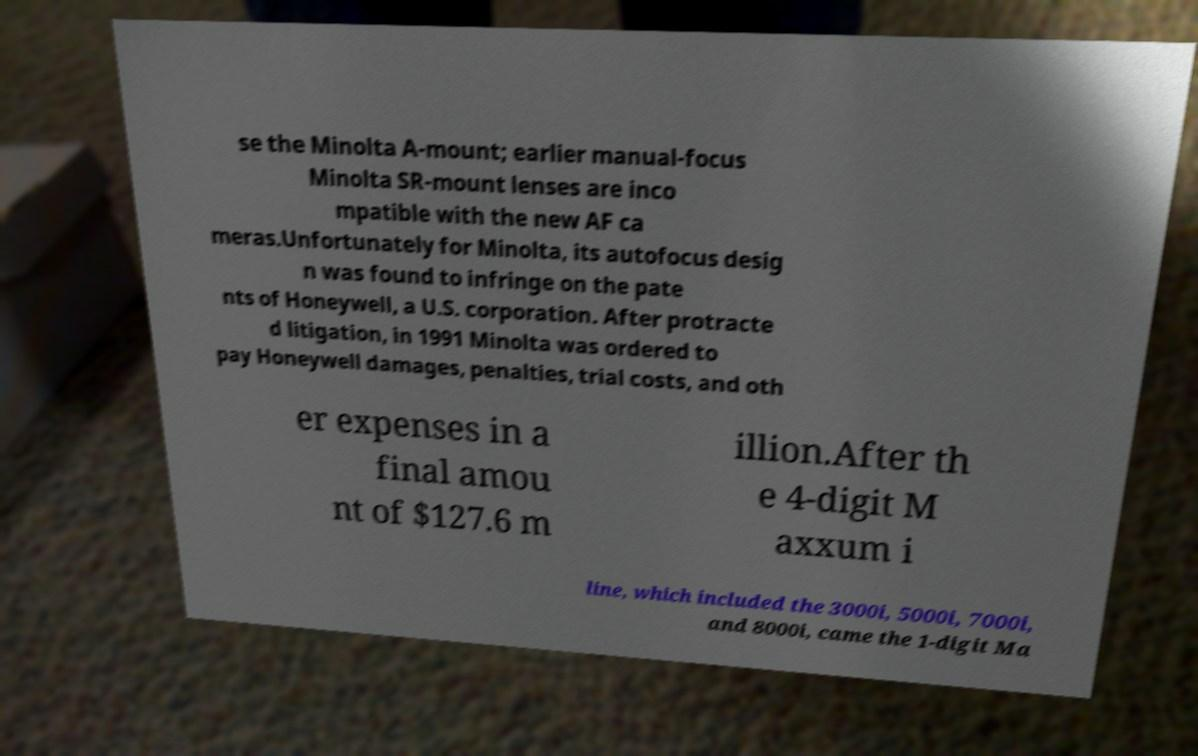Can you read and provide the text displayed in the image?This photo seems to have some interesting text. Can you extract and type it out for me? se the Minolta A-mount; earlier manual-focus Minolta SR-mount lenses are inco mpatible with the new AF ca meras.Unfortunately for Minolta, its autofocus desig n was found to infringe on the pate nts of Honeywell, a U.S. corporation. After protracte d litigation, in 1991 Minolta was ordered to pay Honeywell damages, penalties, trial costs, and oth er expenses in a final amou nt of $127.6 m illion.After th e 4-digit M axxum i line, which included the 3000i, 5000i, 7000i, and 8000i, came the 1-digit Ma 